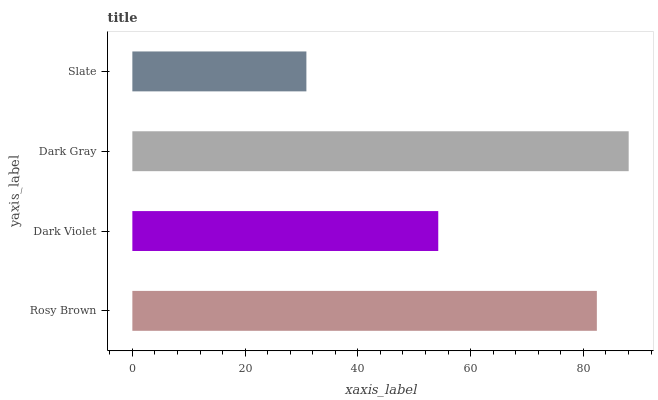Is Slate the minimum?
Answer yes or no. Yes. Is Dark Gray the maximum?
Answer yes or no. Yes. Is Dark Violet the minimum?
Answer yes or no. No. Is Dark Violet the maximum?
Answer yes or no. No. Is Rosy Brown greater than Dark Violet?
Answer yes or no. Yes. Is Dark Violet less than Rosy Brown?
Answer yes or no. Yes. Is Dark Violet greater than Rosy Brown?
Answer yes or no. No. Is Rosy Brown less than Dark Violet?
Answer yes or no. No. Is Rosy Brown the high median?
Answer yes or no. Yes. Is Dark Violet the low median?
Answer yes or no. Yes. Is Slate the high median?
Answer yes or no. No. Is Slate the low median?
Answer yes or no. No. 